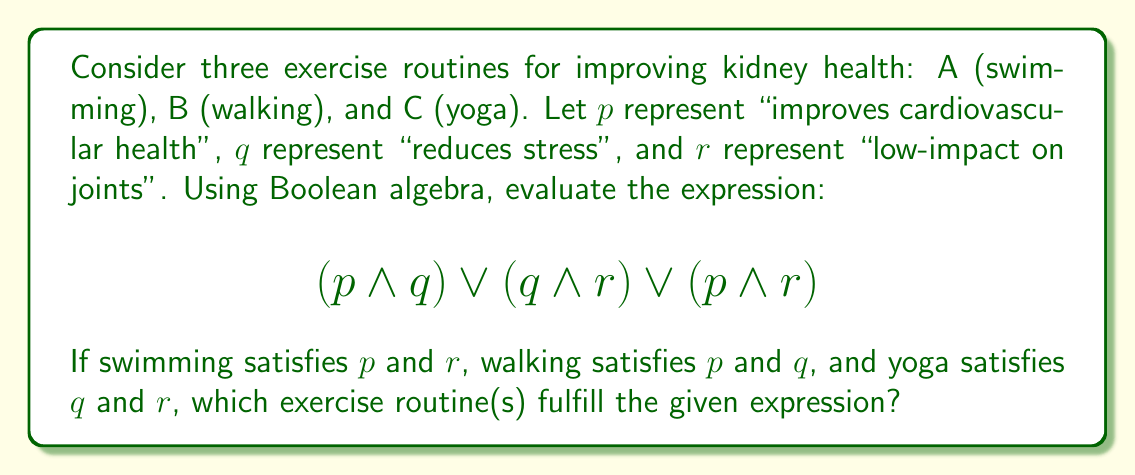Help me with this question. Let's evaluate the expression for each exercise routine:

1. Swimming (A): $p = 1, q = 0, r = 1$
   $$(1 \land 0) \lor (0 \land 1) \lor (1 \land 1) = 0 \lor 0 \lor 1 = 1$$

2. Walking (B): $p = 1, q = 1, r = 0$
   $$(1 \land 1) \lor (1 \land 0) \lor (1 \land 0) = 1 \lor 0 \lor 0 = 1$$

3. Yoga (C): $p = 0, q = 1, r = 1$
   $$(0 \land 1) \lor (1 \land 1) \lor (0 \land 1) = 0 \lor 1 \lor 0 = 1$$

The expression evaluates to true (1) for all three exercise routines. This means that each routine satisfies at least one of the combinations: (improves cardiovascular health AND reduces stress) OR (reduces stress AND low-impact on joints) OR (improves cardiovascular health AND low-impact on joints).
Answer: A, B, and C 